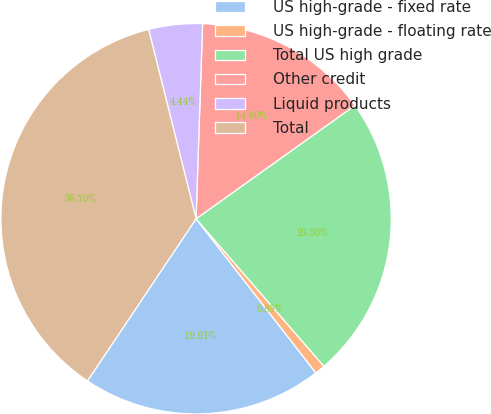Convert chart. <chart><loc_0><loc_0><loc_500><loc_500><pie_chart><fcel>US high-grade - fixed rate<fcel>US high-grade - floating rate<fcel>Total US high grade<fcel>Other credit<fcel>Liquid products<fcel>Total<nl><fcel>19.91%<fcel>0.85%<fcel>23.5%<fcel>14.6%<fcel>4.44%<fcel>36.7%<nl></chart> 